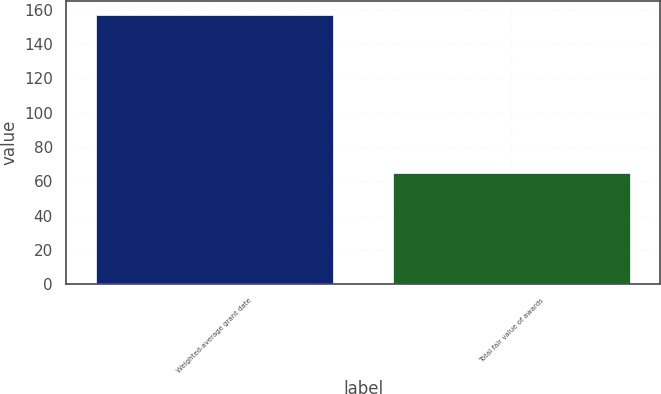<chart> <loc_0><loc_0><loc_500><loc_500><bar_chart><fcel>Weighted-average grant date<fcel>Total fair value of awards<nl><fcel>157.1<fcel>65<nl></chart> 